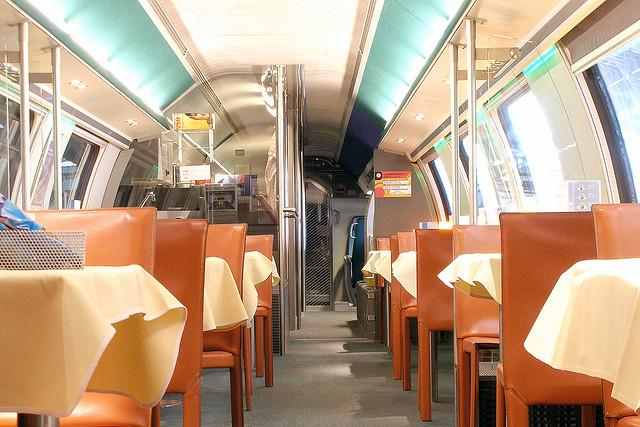Where is this dining room located in all likelihood? train 